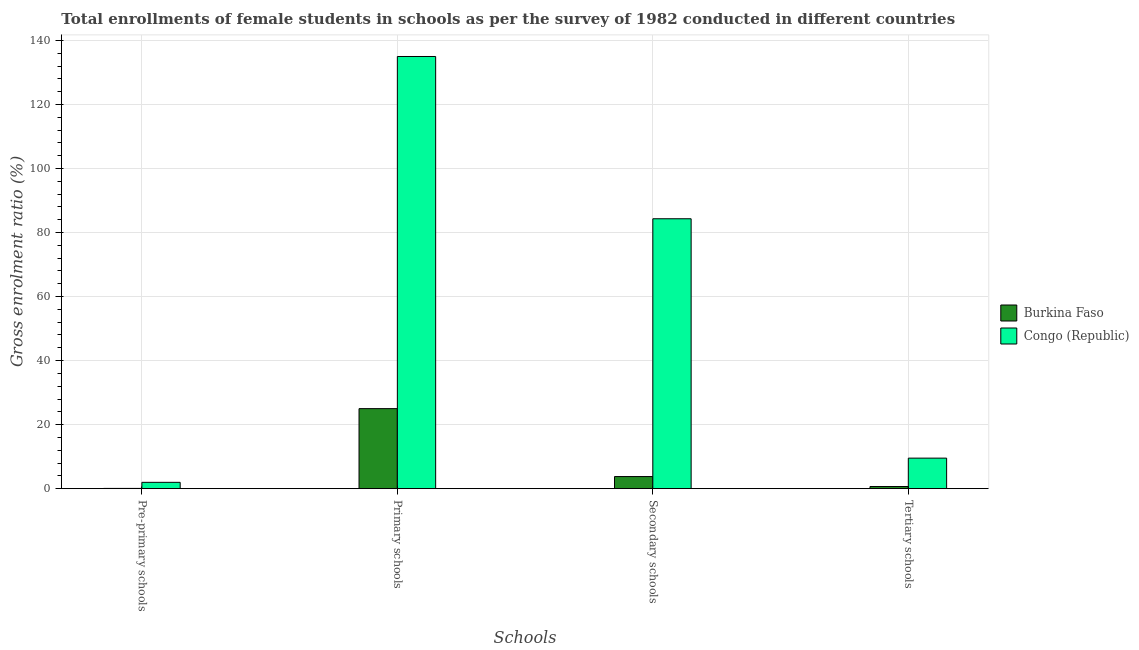How many groups of bars are there?
Your answer should be compact. 4. Are the number of bars per tick equal to the number of legend labels?
Provide a short and direct response. Yes. Are the number of bars on each tick of the X-axis equal?
Your response must be concise. Yes. How many bars are there on the 2nd tick from the left?
Provide a short and direct response. 2. What is the label of the 2nd group of bars from the left?
Provide a short and direct response. Primary schools. What is the gross enrolment ratio(female) in secondary schools in Congo (Republic)?
Offer a terse response. 84.3. Across all countries, what is the maximum gross enrolment ratio(female) in secondary schools?
Offer a terse response. 84.3. Across all countries, what is the minimum gross enrolment ratio(female) in pre-primary schools?
Offer a very short reply. 0.08. In which country was the gross enrolment ratio(female) in pre-primary schools maximum?
Ensure brevity in your answer.  Congo (Republic). In which country was the gross enrolment ratio(female) in tertiary schools minimum?
Offer a terse response. Burkina Faso. What is the total gross enrolment ratio(female) in primary schools in the graph?
Your response must be concise. 159.98. What is the difference between the gross enrolment ratio(female) in tertiary schools in Congo (Republic) and that in Burkina Faso?
Your answer should be very brief. 8.87. What is the difference between the gross enrolment ratio(female) in pre-primary schools in Congo (Republic) and the gross enrolment ratio(female) in secondary schools in Burkina Faso?
Your response must be concise. -1.81. What is the average gross enrolment ratio(female) in secondary schools per country?
Offer a very short reply. 44.05. What is the difference between the gross enrolment ratio(female) in primary schools and gross enrolment ratio(female) in secondary schools in Congo (Republic)?
Offer a very short reply. 50.68. What is the ratio of the gross enrolment ratio(female) in secondary schools in Congo (Republic) to that in Burkina Faso?
Your answer should be very brief. 22.26. Is the gross enrolment ratio(female) in secondary schools in Congo (Republic) less than that in Burkina Faso?
Offer a very short reply. No. Is the difference between the gross enrolment ratio(female) in primary schools in Burkina Faso and Congo (Republic) greater than the difference between the gross enrolment ratio(female) in secondary schools in Burkina Faso and Congo (Republic)?
Keep it short and to the point. No. What is the difference between the highest and the second highest gross enrolment ratio(female) in tertiary schools?
Ensure brevity in your answer.  8.87. What is the difference between the highest and the lowest gross enrolment ratio(female) in secondary schools?
Make the answer very short. 80.52. In how many countries, is the gross enrolment ratio(female) in tertiary schools greater than the average gross enrolment ratio(female) in tertiary schools taken over all countries?
Offer a terse response. 1. Is the sum of the gross enrolment ratio(female) in primary schools in Burkina Faso and Congo (Republic) greater than the maximum gross enrolment ratio(female) in pre-primary schools across all countries?
Provide a succinct answer. Yes. What does the 2nd bar from the left in Tertiary schools represents?
Give a very brief answer. Congo (Republic). What does the 2nd bar from the right in Secondary schools represents?
Provide a short and direct response. Burkina Faso. Is it the case that in every country, the sum of the gross enrolment ratio(female) in pre-primary schools and gross enrolment ratio(female) in primary schools is greater than the gross enrolment ratio(female) in secondary schools?
Provide a succinct answer. Yes. How many bars are there?
Make the answer very short. 8. Are all the bars in the graph horizontal?
Provide a succinct answer. No. How many countries are there in the graph?
Your answer should be compact. 2. Does the graph contain grids?
Make the answer very short. Yes. Where does the legend appear in the graph?
Make the answer very short. Center right. How many legend labels are there?
Your answer should be compact. 2. What is the title of the graph?
Offer a very short reply. Total enrollments of female students in schools as per the survey of 1982 conducted in different countries. Does "Zambia" appear as one of the legend labels in the graph?
Give a very brief answer. No. What is the label or title of the X-axis?
Your answer should be very brief. Schools. What is the label or title of the Y-axis?
Provide a short and direct response. Gross enrolment ratio (%). What is the Gross enrolment ratio (%) of Burkina Faso in Pre-primary schools?
Keep it short and to the point. 0.08. What is the Gross enrolment ratio (%) in Congo (Republic) in Pre-primary schools?
Provide a short and direct response. 1.98. What is the Gross enrolment ratio (%) in Burkina Faso in Primary schools?
Keep it short and to the point. 25. What is the Gross enrolment ratio (%) in Congo (Republic) in Primary schools?
Your response must be concise. 134.99. What is the Gross enrolment ratio (%) in Burkina Faso in Secondary schools?
Provide a short and direct response. 3.79. What is the Gross enrolment ratio (%) of Congo (Republic) in Secondary schools?
Offer a very short reply. 84.3. What is the Gross enrolment ratio (%) in Burkina Faso in Tertiary schools?
Provide a succinct answer. 0.67. What is the Gross enrolment ratio (%) of Congo (Republic) in Tertiary schools?
Ensure brevity in your answer.  9.54. Across all Schools, what is the maximum Gross enrolment ratio (%) in Burkina Faso?
Provide a short and direct response. 25. Across all Schools, what is the maximum Gross enrolment ratio (%) in Congo (Republic)?
Make the answer very short. 134.99. Across all Schools, what is the minimum Gross enrolment ratio (%) of Burkina Faso?
Your response must be concise. 0.08. Across all Schools, what is the minimum Gross enrolment ratio (%) of Congo (Republic)?
Give a very brief answer. 1.98. What is the total Gross enrolment ratio (%) of Burkina Faso in the graph?
Provide a succinct answer. 29.54. What is the total Gross enrolment ratio (%) in Congo (Republic) in the graph?
Your answer should be compact. 230.81. What is the difference between the Gross enrolment ratio (%) in Burkina Faso in Pre-primary schools and that in Primary schools?
Offer a very short reply. -24.92. What is the difference between the Gross enrolment ratio (%) of Congo (Republic) in Pre-primary schools and that in Primary schools?
Your response must be concise. -133.01. What is the difference between the Gross enrolment ratio (%) in Burkina Faso in Pre-primary schools and that in Secondary schools?
Ensure brevity in your answer.  -3.71. What is the difference between the Gross enrolment ratio (%) of Congo (Republic) in Pre-primary schools and that in Secondary schools?
Offer a terse response. -82.33. What is the difference between the Gross enrolment ratio (%) of Burkina Faso in Pre-primary schools and that in Tertiary schools?
Offer a very short reply. -0.59. What is the difference between the Gross enrolment ratio (%) of Congo (Republic) in Pre-primary schools and that in Tertiary schools?
Ensure brevity in your answer.  -7.56. What is the difference between the Gross enrolment ratio (%) in Burkina Faso in Primary schools and that in Secondary schools?
Give a very brief answer. 21.21. What is the difference between the Gross enrolment ratio (%) of Congo (Republic) in Primary schools and that in Secondary schools?
Keep it short and to the point. 50.68. What is the difference between the Gross enrolment ratio (%) in Burkina Faso in Primary schools and that in Tertiary schools?
Provide a succinct answer. 24.32. What is the difference between the Gross enrolment ratio (%) of Congo (Republic) in Primary schools and that in Tertiary schools?
Give a very brief answer. 125.45. What is the difference between the Gross enrolment ratio (%) in Burkina Faso in Secondary schools and that in Tertiary schools?
Your response must be concise. 3.11. What is the difference between the Gross enrolment ratio (%) in Congo (Republic) in Secondary schools and that in Tertiary schools?
Offer a terse response. 74.77. What is the difference between the Gross enrolment ratio (%) in Burkina Faso in Pre-primary schools and the Gross enrolment ratio (%) in Congo (Republic) in Primary schools?
Keep it short and to the point. -134.9. What is the difference between the Gross enrolment ratio (%) in Burkina Faso in Pre-primary schools and the Gross enrolment ratio (%) in Congo (Republic) in Secondary schools?
Provide a short and direct response. -84.22. What is the difference between the Gross enrolment ratio (%) in Burkina Faso in Pre-primary schools and the Gross enrolment ratio (%) in Congo (Republic) in Tertiary schools?
Provide a short and direct response. -9.46. What is the difference between the Gross enrolment ratio (%) in Burkina Faso in Primary schools and the Gross enrolment ratio (%) in Congo (Republic) in Secondary schools?
Give a very brief answer. -59.31. What is the difference between the Gross enrolment ratio (%) of Burkina Faso in Primary schools and the Gross enrolment ratio (%) of Congo (Republic) in Tertiary schools?
Your answer should be compact. 15.46. What is the difference between the Gross enrolment ratio (%) of Burkina Faso in Secondary schools and the Gross enrolment ratio (%) of Congo (Republic) in Tertiary schools?
Your answer should be compact. -5.75. What is the average Gross enrolment ratio (%) in Burkina Faso per Schools?
Offer a terse response. 7.39. What is the average Gross enrolment ratio (%) of Congo (Republic) per Schools?
Make the answer very short. 57.7. What is the difference between the Gross enrolment ratio (%) in Burkina Faso and Gross enrolment ratio (%) in Congo (Republic) in Pre-primary schools?
Offer a terse response. -1.9. What is the difference between the Gross enrolment ratio (%) of Burkina Faso and Gross enrolment ratio (%) of Congo (Republic) in Primary schools?
Make the answer very short. -109.99. What is the difference between the Gross enrolment ratio (%) of Burkina Faso and Gross enrolment ratio (%) of Congo (Republic) in Secondary schools?
Provide a succinct answer. -80.52. What is the difference between the Gross enrolment ratio (%) of Burkina Faso and Gross enrolment ratio (%) of Congo (Republic) in Tertiary schools?
Give a very brief answer. -8.87. What is the ratio of the Gross enrolment ratio (%) of Burkina Faso in Pre-primary schools to that in Primary schools?
Make the answer very short. 0. What is the ratio of the Gross enrolment ratio (%) of Congo (Republic) in Pre-primary schools to that in Primary schools?
Provide a succinct answer. 0.01. What is the ratio of the Gross enrolment ratio (%) in Burkina Faso in Pre-primary schools to that in Secondary schools?
Keep it short and to the point. 0.02. What is the ratio of the Gross enrolment ratio (%) in Congo (Republic) in Pre-primary schools to that in Secondary schools?
Make the answer very short. 0.02. What is the ratio of the Gross enrolment ratio (%) of Burkina Faso in Pre-primary schools to that in Tertiary schools?
Provide a short and direct response. 0.12. What is the ratio of the Gross enrolment ratio (%) in Congo (Republic) in Pre-primary schools to that in Tertiary schools?
Keep it short and to the point. 0.21. What is the ratio of the Gross enrolment ratio (%) in Burkina Faso in Primary schools to that in Secondary schools?
Your answer should be very brief. 6.6. What is the ratio of the Gross enrolment ratio (%) in Congo (Republic) in Primary schools to that in Secondary schools?
Your response must be concise. 1.6. What is the ratio of the Gross enrolment ratio (%) of Burkina Faso in Primary schools to that in Tertiary schools?
Provide a short and direct response. 37.08. What is the ratio of the Gross enrolment ratio (%) of Congo (Republic) in Primary schools to that in Tertiary schools?
Offer a very short reply. 14.15. What is the ratio of the Gross enrolment ratio (%) in Burkina Faso in Secondary schools to that in Tertiary schools?
Provide a short and direct response. 5.62. What is the ratio of the Gross enrolment ratio (%) of Congo (Republic) in Secondary schools to that in Tertiary schools?
Make the answer very short. 8.84. What is the difference between the highest and the second highest Gross enrolment ratio (%) of Burkina Faso?
Offer a very short reply. 21.21. What is the difference between the highest and the second highest Gross enrolment ratio (%) of Congo (Republic)?
Ensure brevity in your answer.  50.68. What is the difference between the highest and the lowest Gross enrolment ratio (%) of Burkina Faso?
Offer a terse response. 24.92. What is the difference between the highest and the lowest Gross enrolment ratio (%) in Congo (Republic)?
Ensure brevity in your answer.  133.01. 